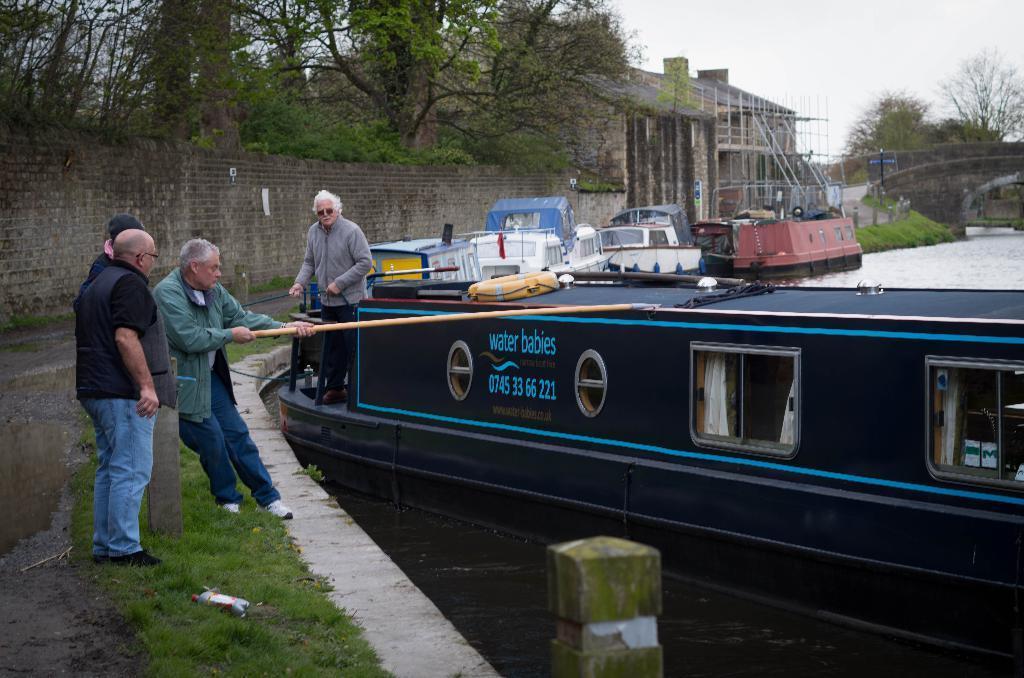How would you summarize this image in a sentence or two? This image consists of many boats. There are four persons in this image. At the bottom, there is water. On the left, we can see green grass on the ground. In the background, there is a wall along with trees. At the top, there is sky. 